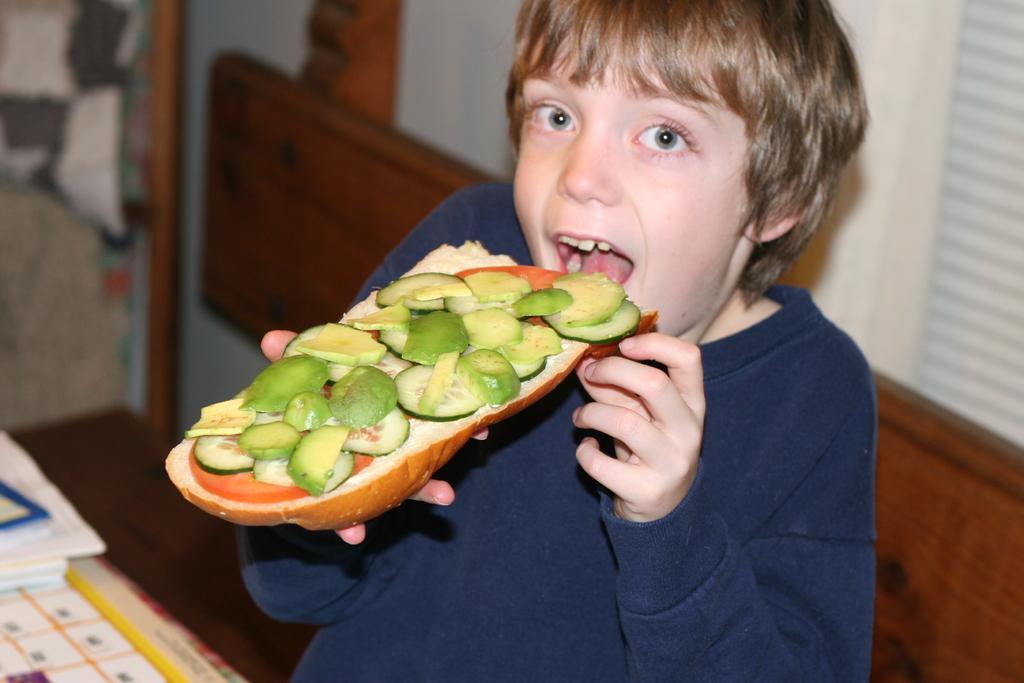Describe this image in one or two sentences. In this image we can see a boy holding the food item. We can also see the books and a chart on the table. We can see the bench, wall and also the window and some part is not clear on the left. 